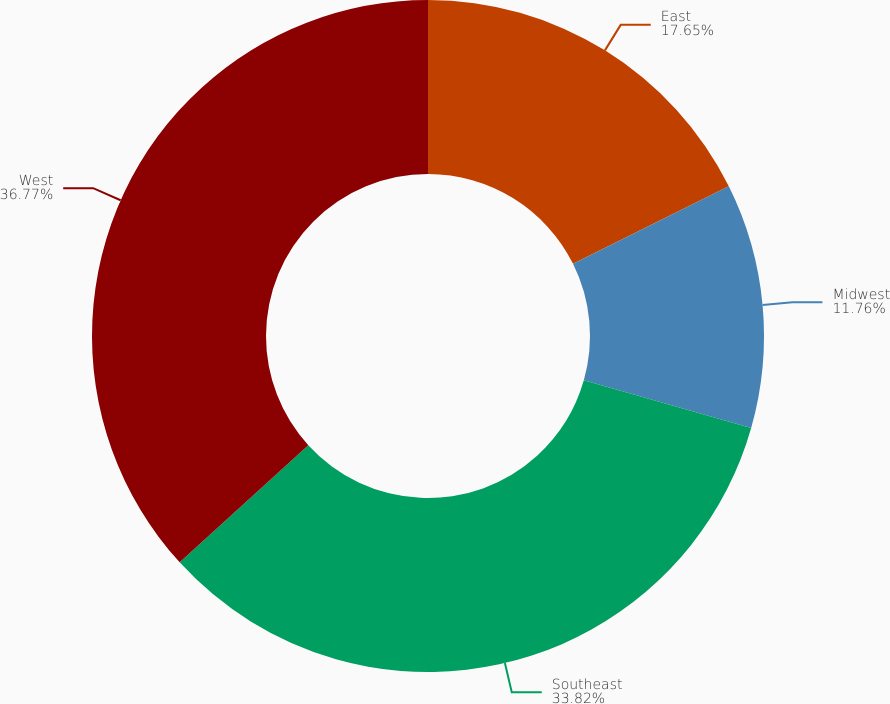Convert chart. <chart><loc_0><loc_0><loc_500><loc_500><pie_chart><fcel>East<fcel>Midwest<fcel>Southeast<fcel>West<nl><fcel>17.65%<fcel>11.76%<fcel>33.82%<fcel>36.76%<nl></chart> 